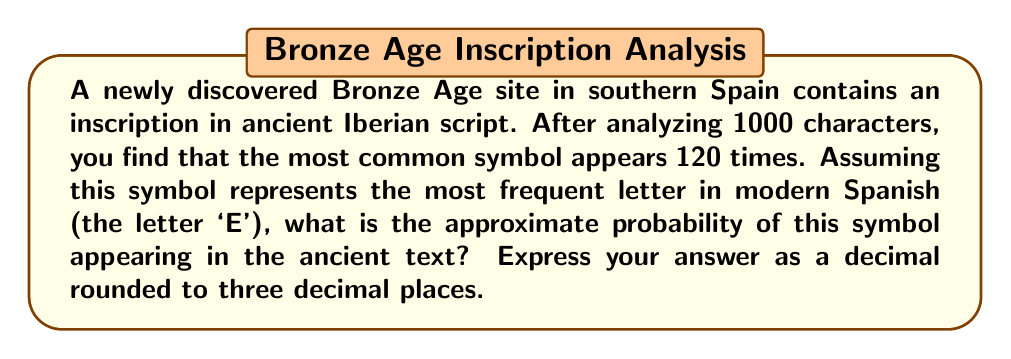Help me with this question. To solve this problem, we need to follow these steps:

1. Identify the total number of characters analyzed:
   $N = 1000$

2. Identify the number of times the most common symbol appears:
   $n = 120$

3. Calculate the probability by dividing the number of occurrences by the total number of characters:
   $P = \frac{n}{N} = \frac{120}{1000}$

4. Simplify the fraction:
   $P = \frac{120}{1000} = \frac{12}{100} = 0.12$

5. Round the result to three decimal places:
   $P \approx 0.120$

This probability (0.120 or 12%) is consistent with the frequency of the letter 'E' in modern Spanish, which typically ranges from 12% to 14% of all letters in a text. This similarity supports the assumption that the ancient Iberian script might have a comparable frequency distribution to modern Spanish, making frequency analysis a viable method for decoding the script.
Answer: 0.120 